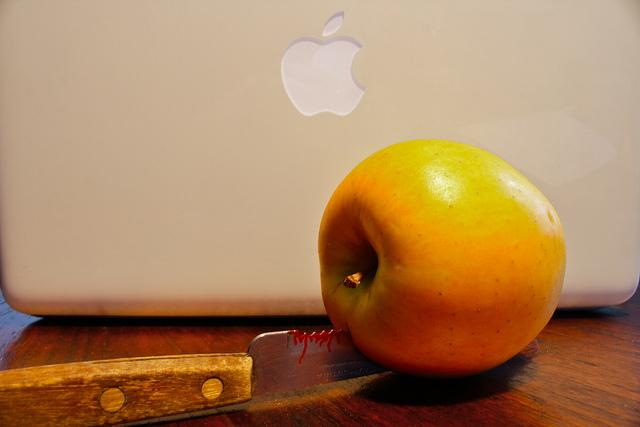What is likely the red substance on the knife?

Choices:
A) blood
B) paint
C) marker
D) crayon paint 